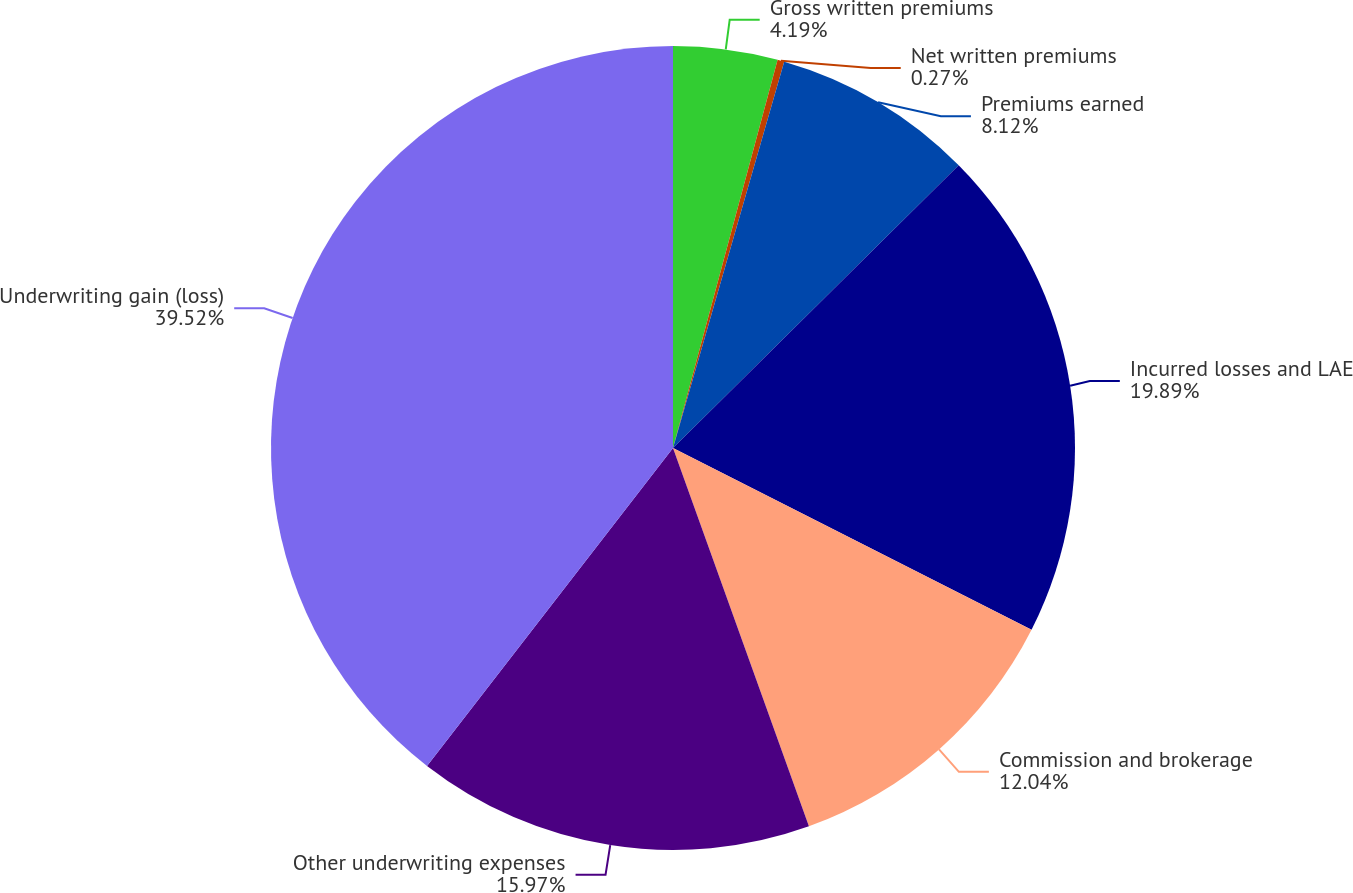Convert chart. <chart><loc_0><loc_0><loc_500><loc_500><pie_chart><fcel>Gross written premiums<fcel>Net written premiums<fcel>Premiums earned<fcel>Incurred losses and LAE<fcel>Commission and brokerage<fcel>Other underwriting expenses<fcel>Underwriting gain (loss)<nl><fcel>4.19%<fcel>0.27%<fcel>8.12%<fcel>19.89%<fcel>12.04%<fcel>15.97%<fcel>39.52%<nl></chart> 